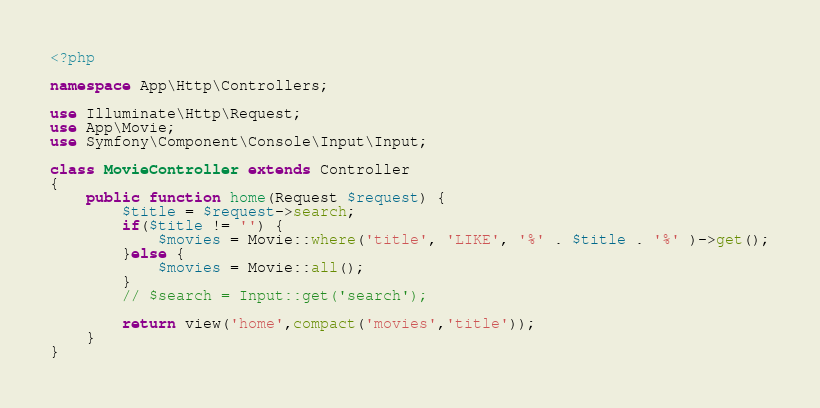Convert code to text. <code><loc_0><loc_0><loc_500><loc_500><_PHP_><?php

namespace App\Http\Controllers;

use Illuminate\Http\Request;
use App\Movie;
use Symfony\Component\Console\Input\Input;

class MovieController extends Controller
{
    public function home(Request $request) {
        $title = $request->search;
        if($title != '') {
            $movies = Movie::where('title', 'LIKE', '%' . $title . '%' )->get();
        }else {
            $movies = Movie::all();
        }
        // $search = Input::get('search');
        
        return view('home',compact('movies','title'));
    }
}
</code> 